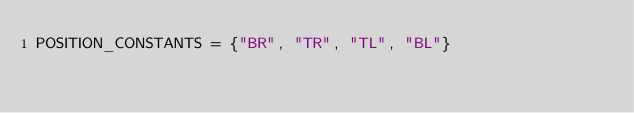<code> <loc_0><loc_0><loc_500><loc_500><_Python_>POSITION_CONSTANTS = {"BR", "TR", "TL", "BL"}
</code> 